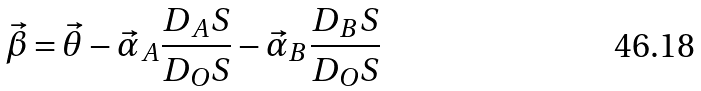<formula> <loc_0><loc_0><loc_500><loc_500>\vec { \beta } = \vec { \theta } - \vec { \alpha } _ { A } \frac { D _ { A } S } { D _ { O } S } - \vec { \alpha } _ { B } \frac { D _ { B } S } { D _ { O } S }</formula> 